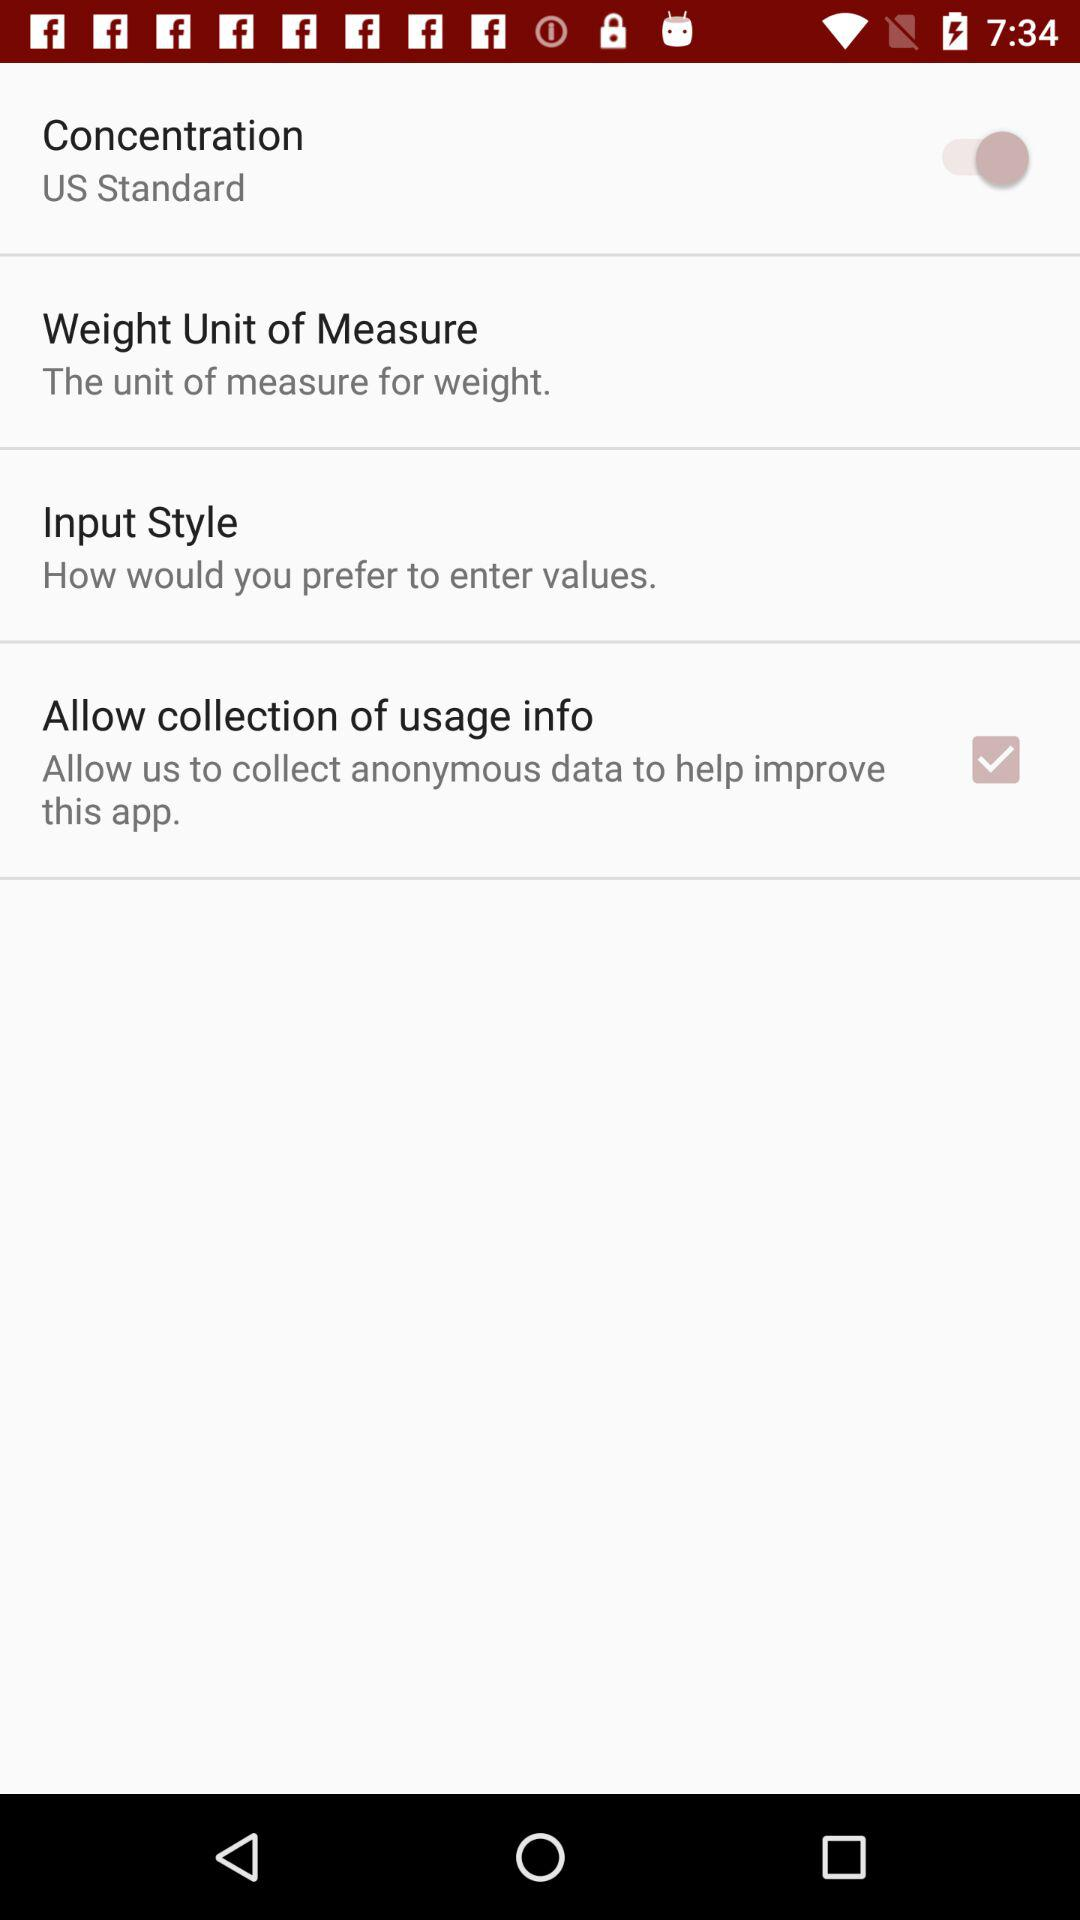What is the status of the concentration? The status of the concentration is "on". 